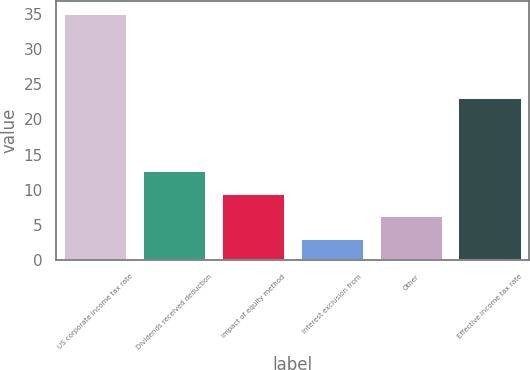Convert chart to OTSL. <chart><loc_0><loc_0><loc_500><loc_500><bar_chart><fcel>US corporate income tax rate<fcel>Dividends received deduction<fcel>Impact of equity method<fcel>Interest exclusion from<fcel>Other<fcel>Effective income tax rate<nl><fcel>35<fcel>12.6<fcel>9.4<fcel>3<fcel>6.2<fcel>23<nl></chart> 